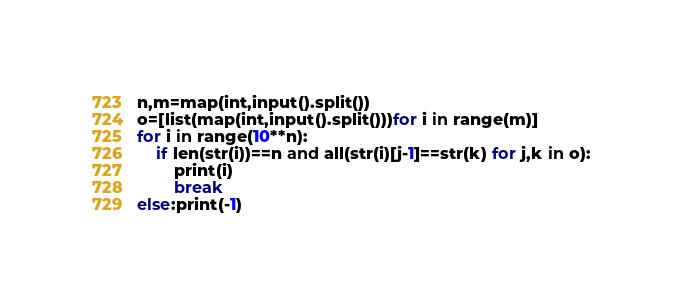Convert code to text. <code><loc_0><loc_0><loc_500><loc_500><_Python_>n,m=map(int,input().split())
o=[list(map(int,input().split()))for i in range(m)]
for i in range(10**n):
    if len(str(i))==n and all(str(i)[j-1]==str(k) for j,k in o):
        print(i)
        break
else:print(-1)
</code> 